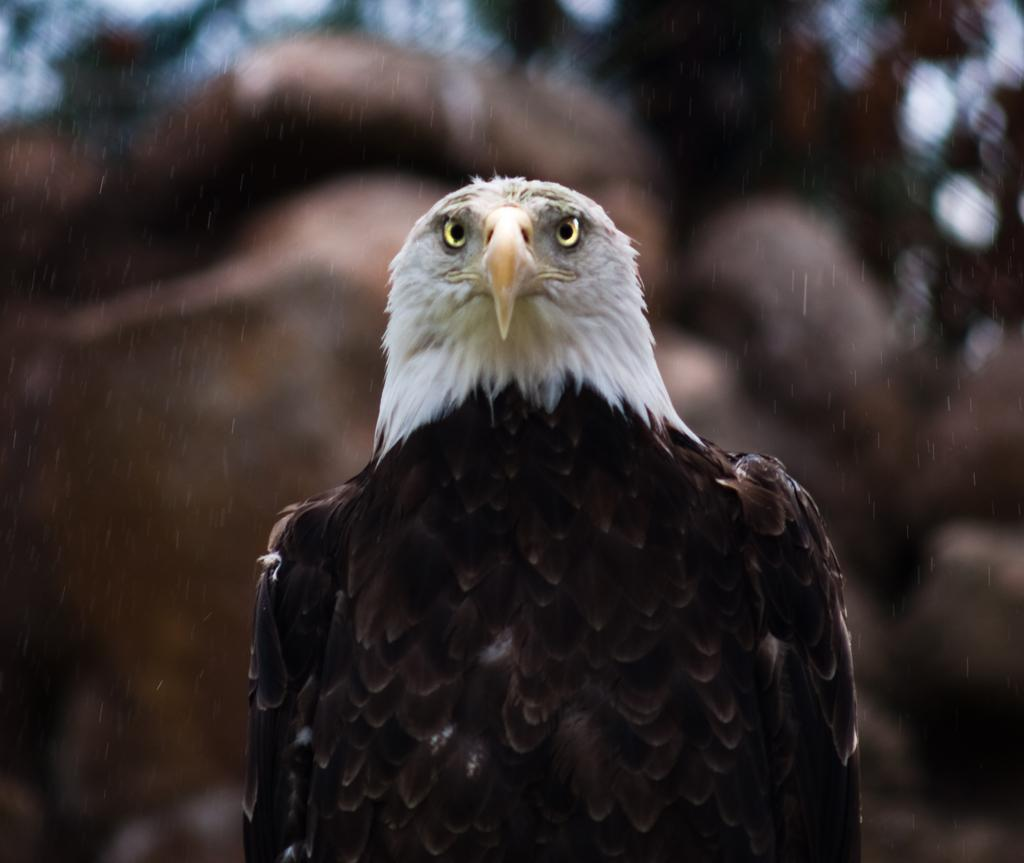What animal is the main subject of the picture? There is an eagle in the picture. Can you describe the background of the image? The background of the image is blurry. Is there a rainstorm happening in the background of the image? There is no indication of a rainstorm in the image; the background is blurry, but no rain or storm is visible. What appliance can be seen in the image? There is no appliance present in the image; it features an eagle and a blurry background. 